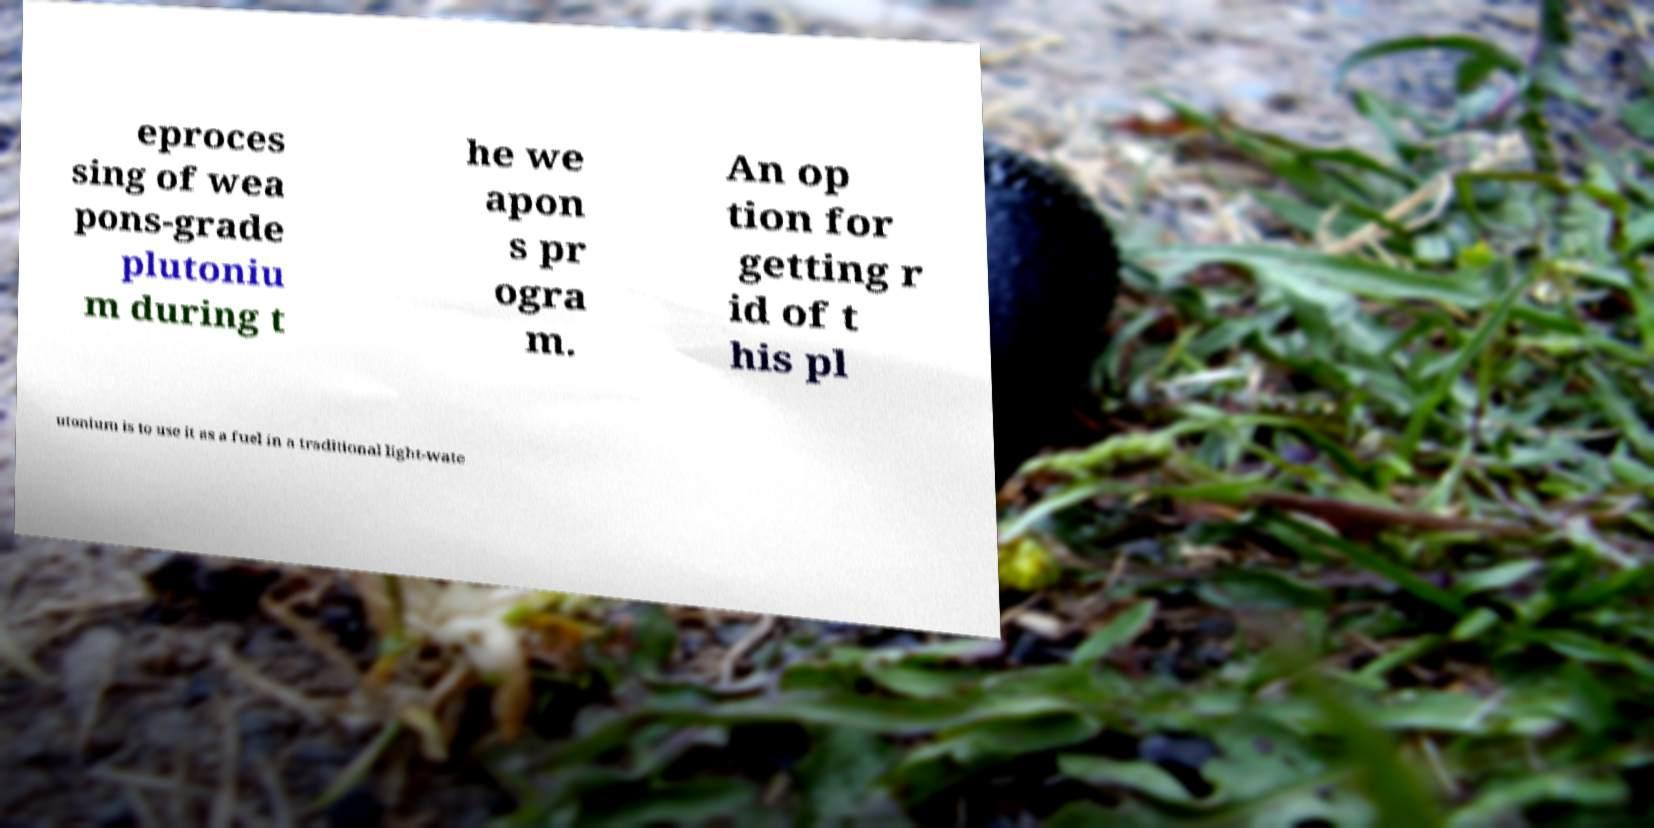There's text embedded in this image that I need extracted. Can you transcribe it verbatim? eproces sing of wea pons-grade plutoniu m during t he we apon s pr ogra m. An op tion for getting r id of t his pl utonium is to use it as a fuel in a traditional light-wate 